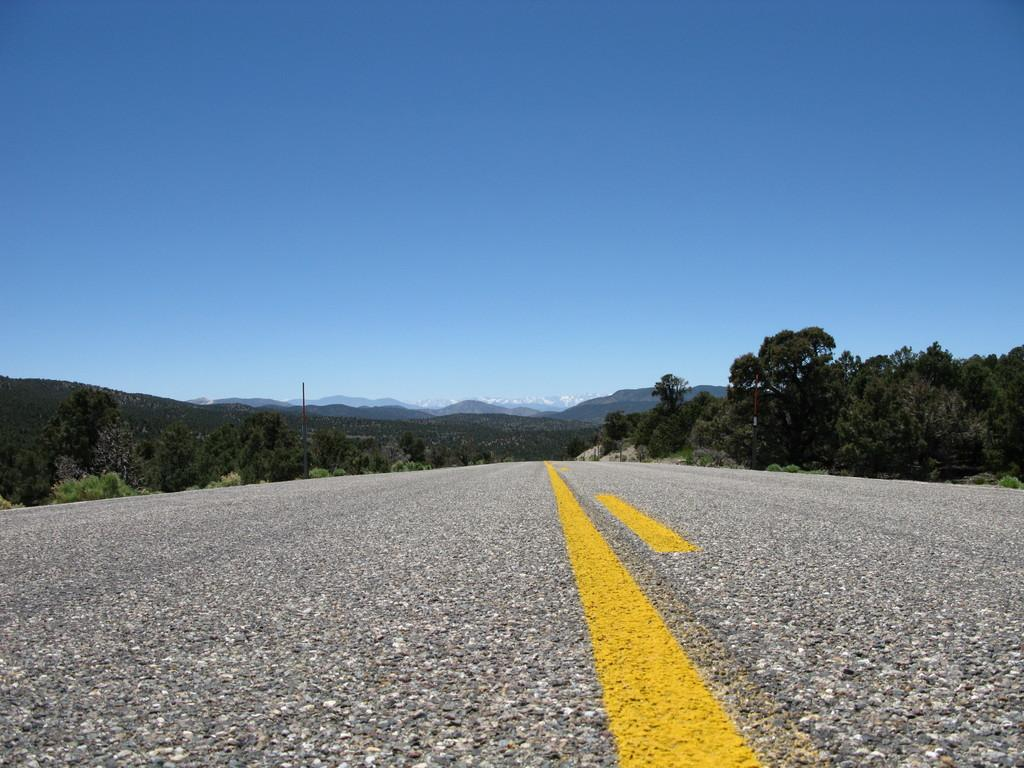What is the main feature of the image? There is a road in the image. What can be seen on either side of the road? There are trees on both sides of the road. What color is the sky in the image? The sky is blue in color. Can you see a toy that dad is holding in the image? There is no toy or dad present in the image; it only features a road, trees, and a blue sky. 